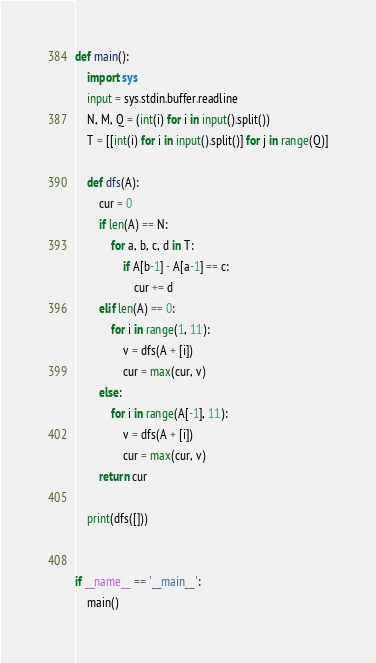Convert code to text. <code><loc_0><loc_0><loc_500><loc_500><_Python_>def main():
    import sys
    input = sys.stdin.buffer.readline
    N, M, Q = (int(i) for i in input().split())
    T = [[int(i) for i in input().split()] for j in range(Q)]

    def dfs(A):
        cur = 0
        if len(A) == N:
            for a, b, c, d in T:
                if A[b-1] - A[a-1] == c:
                    cur += d
        elif len(A) == 0:
            for i in range(1, 11):
                v = dfs(A + [i])
                cur = max(cur, v)
        else:
            for i in range(A[-1], 11):
                v = dfs(A + [i])
                cur = max(cur, v)
        return cur

    print(dfs([]))


if __name__ == '__main__':
    main()
</code> 